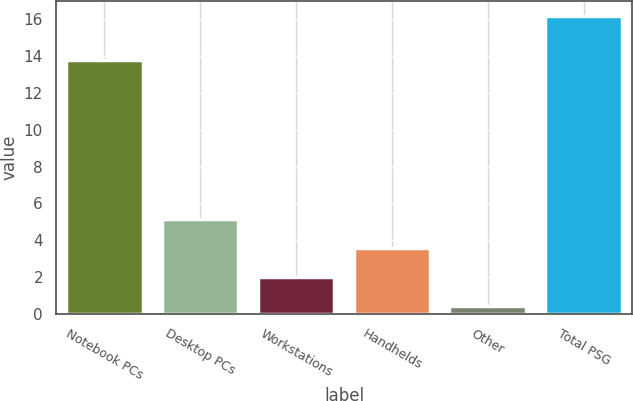<chart> <loc_0><loc_0><loc_500><loc_500><bar_chart><fcel>Notebook PCs<fcel>Desktop PCs<fcel>Workstations<fcel>Handhelds<fcel>Other<fcel>Total PSG<nl><fcel>13.8<fcel>5.14<fcel>1.98<fcel>3.56<fcel>0.4<fcel>16.2<nl></chart> 